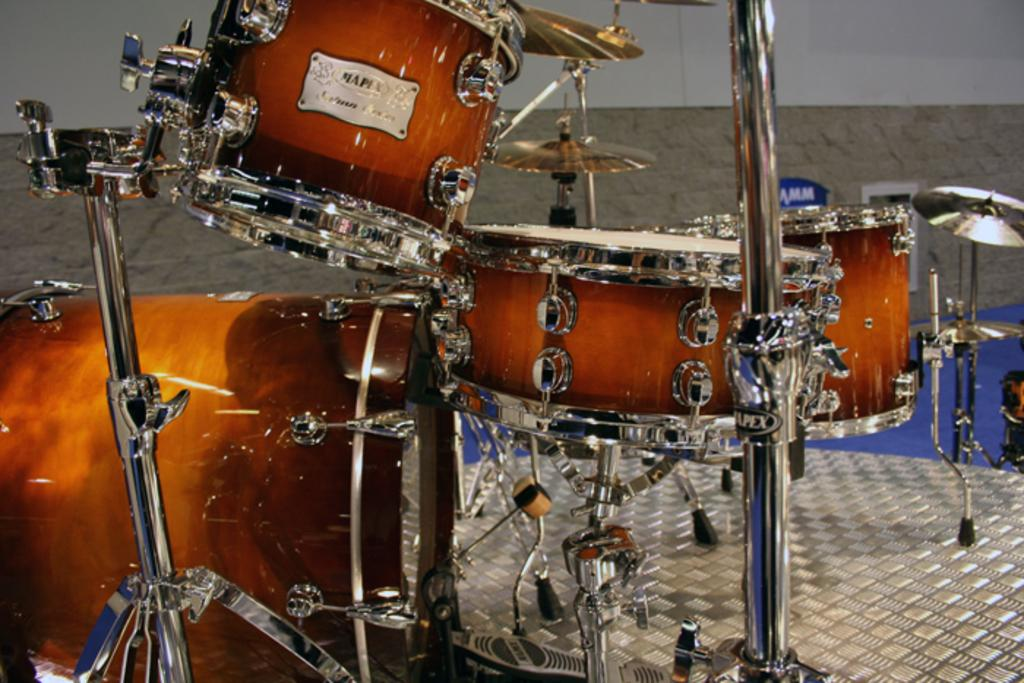What is the main subject of the image? The main subject of the image is musical instruments. What can be seen in the background of the image? There is a wall in the background of the image. What type of flooring is present in the image? There is a carpet in the image. How far away is the summer season from the image? The image does not provide any information about the season or the distance to the summer season. 